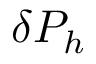<formula> <loc_0><loc_0><loc_500><loc_500>\delta P _ { h }</formula> 